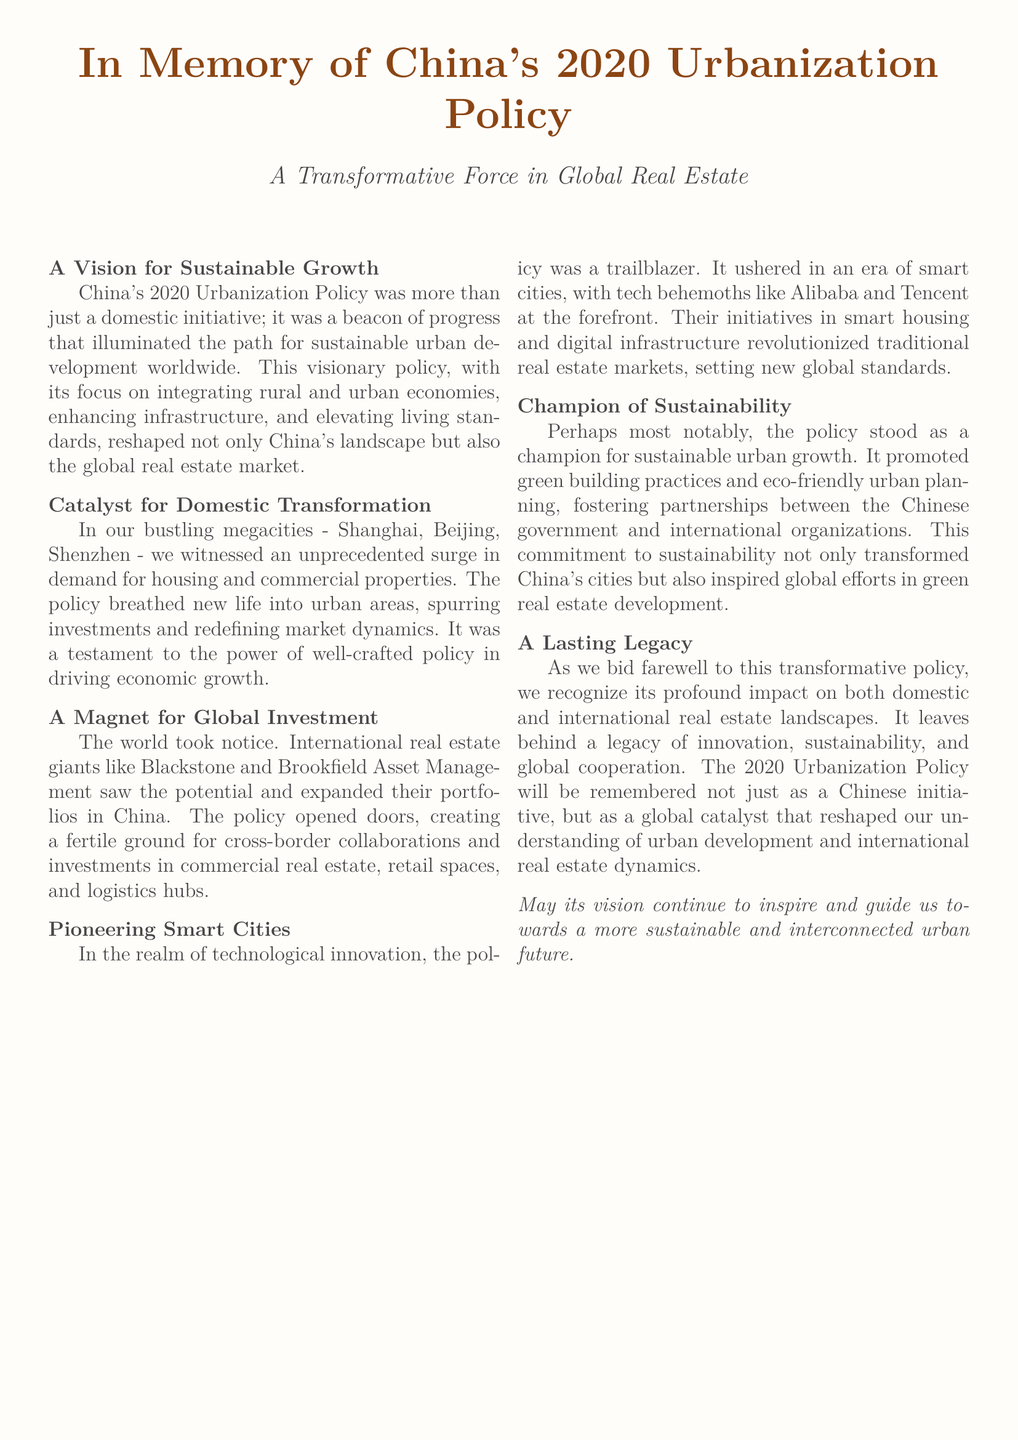What was the primary focus of China's 2020 Urbanization Policy? The primary focus was on integrating rural and urban economies, enhancing infrastructure, and elevating living standards.
Answer: integrating rural and urban economies Which cities in China experienced a surge in demand for housing and commercial properties? The document mentions Shanghai, Beijing, and Shenzhen as cities that witnessed a surge in demand.
Answer: Shanghai, Beijing, Shenzhen What type of investment did international firms like Blackstone and Brookfield engage in China? The firms engaged in investments in commercial real estate, retail spaces, and logistics hubs due to the policy.
Answer: commercial real estate, retail spaces, and logistics hubs Who were the tech behemoths leading the initiatives in smart housing? The document identifies Alibaba and Tencent as the tech behemoths at the forefront of smart housing initiatives.
Answer: Alibaba and Tencent What aspect did the Urbanization Policy champion that relates to environmental concerns? The policy championed sustainable urban growth and promoted green building practices and eco-friendly urban planning.
Answer: sustainable urban growth What legacy does the document suggest the Urbanization Policy will leave? The legacy includes innovation, sustainability, and global cooperation in real estate development.
Answer: innovation, sustainability, and global cooperation What did the Urbanization Policy inspire in terms of global efforts? The policy inspired global efforts in green real estate development.
Answer: green real estate development When is China's 2020 Urbanization Policy remembered as a global catalyst? It is remembered as a global catalyst that reshaped understanding of urban development and international real estate dynamics.
Answer: reshaped understanding of urban development and international real estate dynamics 